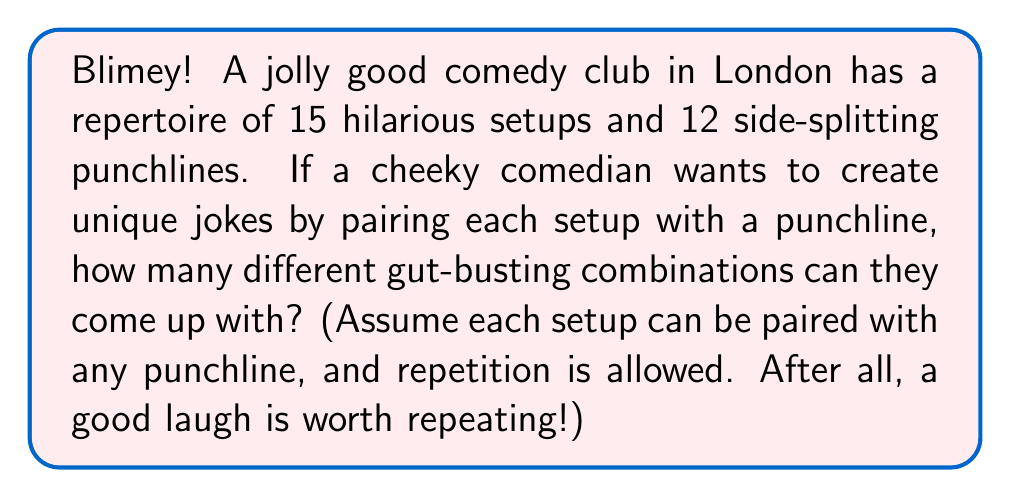Solve this math problem. Let's break this down step by step, shall we?

1) We're dealing with a classic case of the multiplication principle here. Each joke consists of two parts: a setup and a punchline.

2) For each setup, we have 12 punchlines to choose from. This is because:
   - We're allowed to use any punchline with any setup
   - Repetition is allowed (a punchline can be used with multiple setups)

3) Now, we have 15 setups, and for each of these setups, we have 12 choices for the punchline.

4) According to the multiplication principle, when we have a series of independent choices, we multiply the number of possibilities for each choice.

5) Therefore, the total number of possible jokes is:

   $$ \text{Number of jokes} = \text{Number of setups} \times \text{Number of punchlines} $$

   $$ = 15 \times 12 $$

   $$ = 180 $$

So, our witty comedian can create 180 different jokes, enough to keep the audience in stitches all night long!
Answer: $180$ possible jokes 